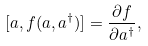<formula> <loc_0><loc_0><loc_500><loc_500>[ a , f ( a , a ^ { \dag } ) ] = \frac { \partial f } { \partial a ^ { \dag } } ,</formula> 